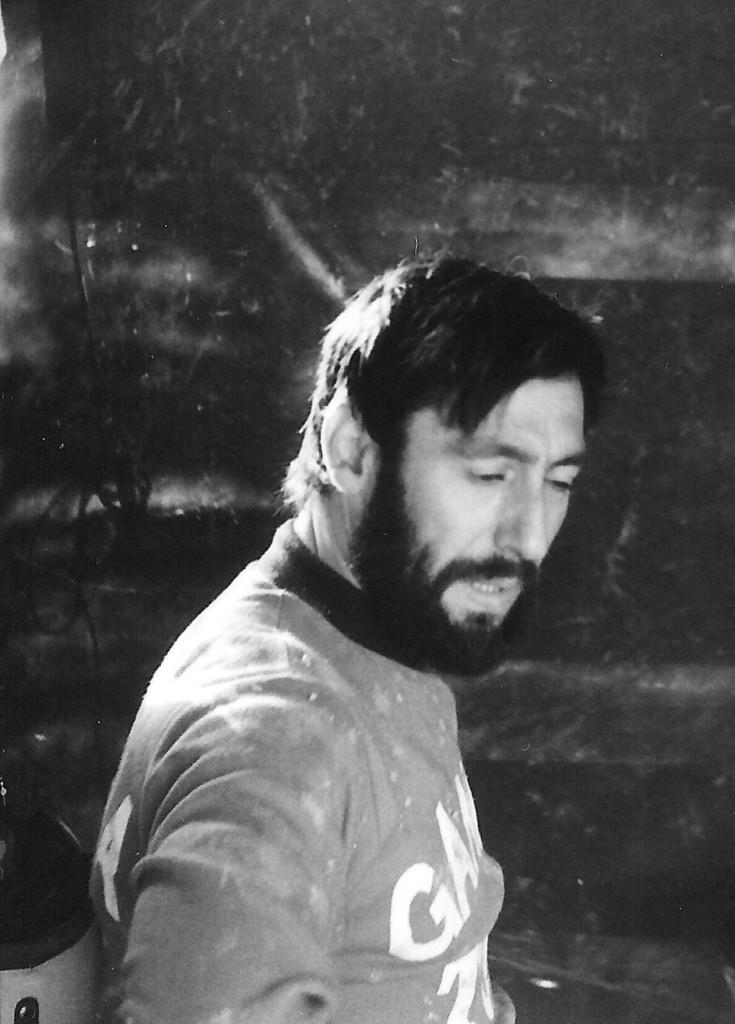What is the color scheme of the image? The image is black and white. Who is present in the image? There is a man in the image. What is the man wearing? The man is wearing a t-shirt. What is the man doing in the image? The man is sitting on a chair and looking downwards. How is the background of the image depicted? The background of the image is blurred. What type of bells can be heard ringing in the image? There are no bells present in the image, and therefore no sound can be heard. Is the man wearing a mitten in the image? There is no mention of a mitten in the image, and the man is only described as wearing a t-shirt. 